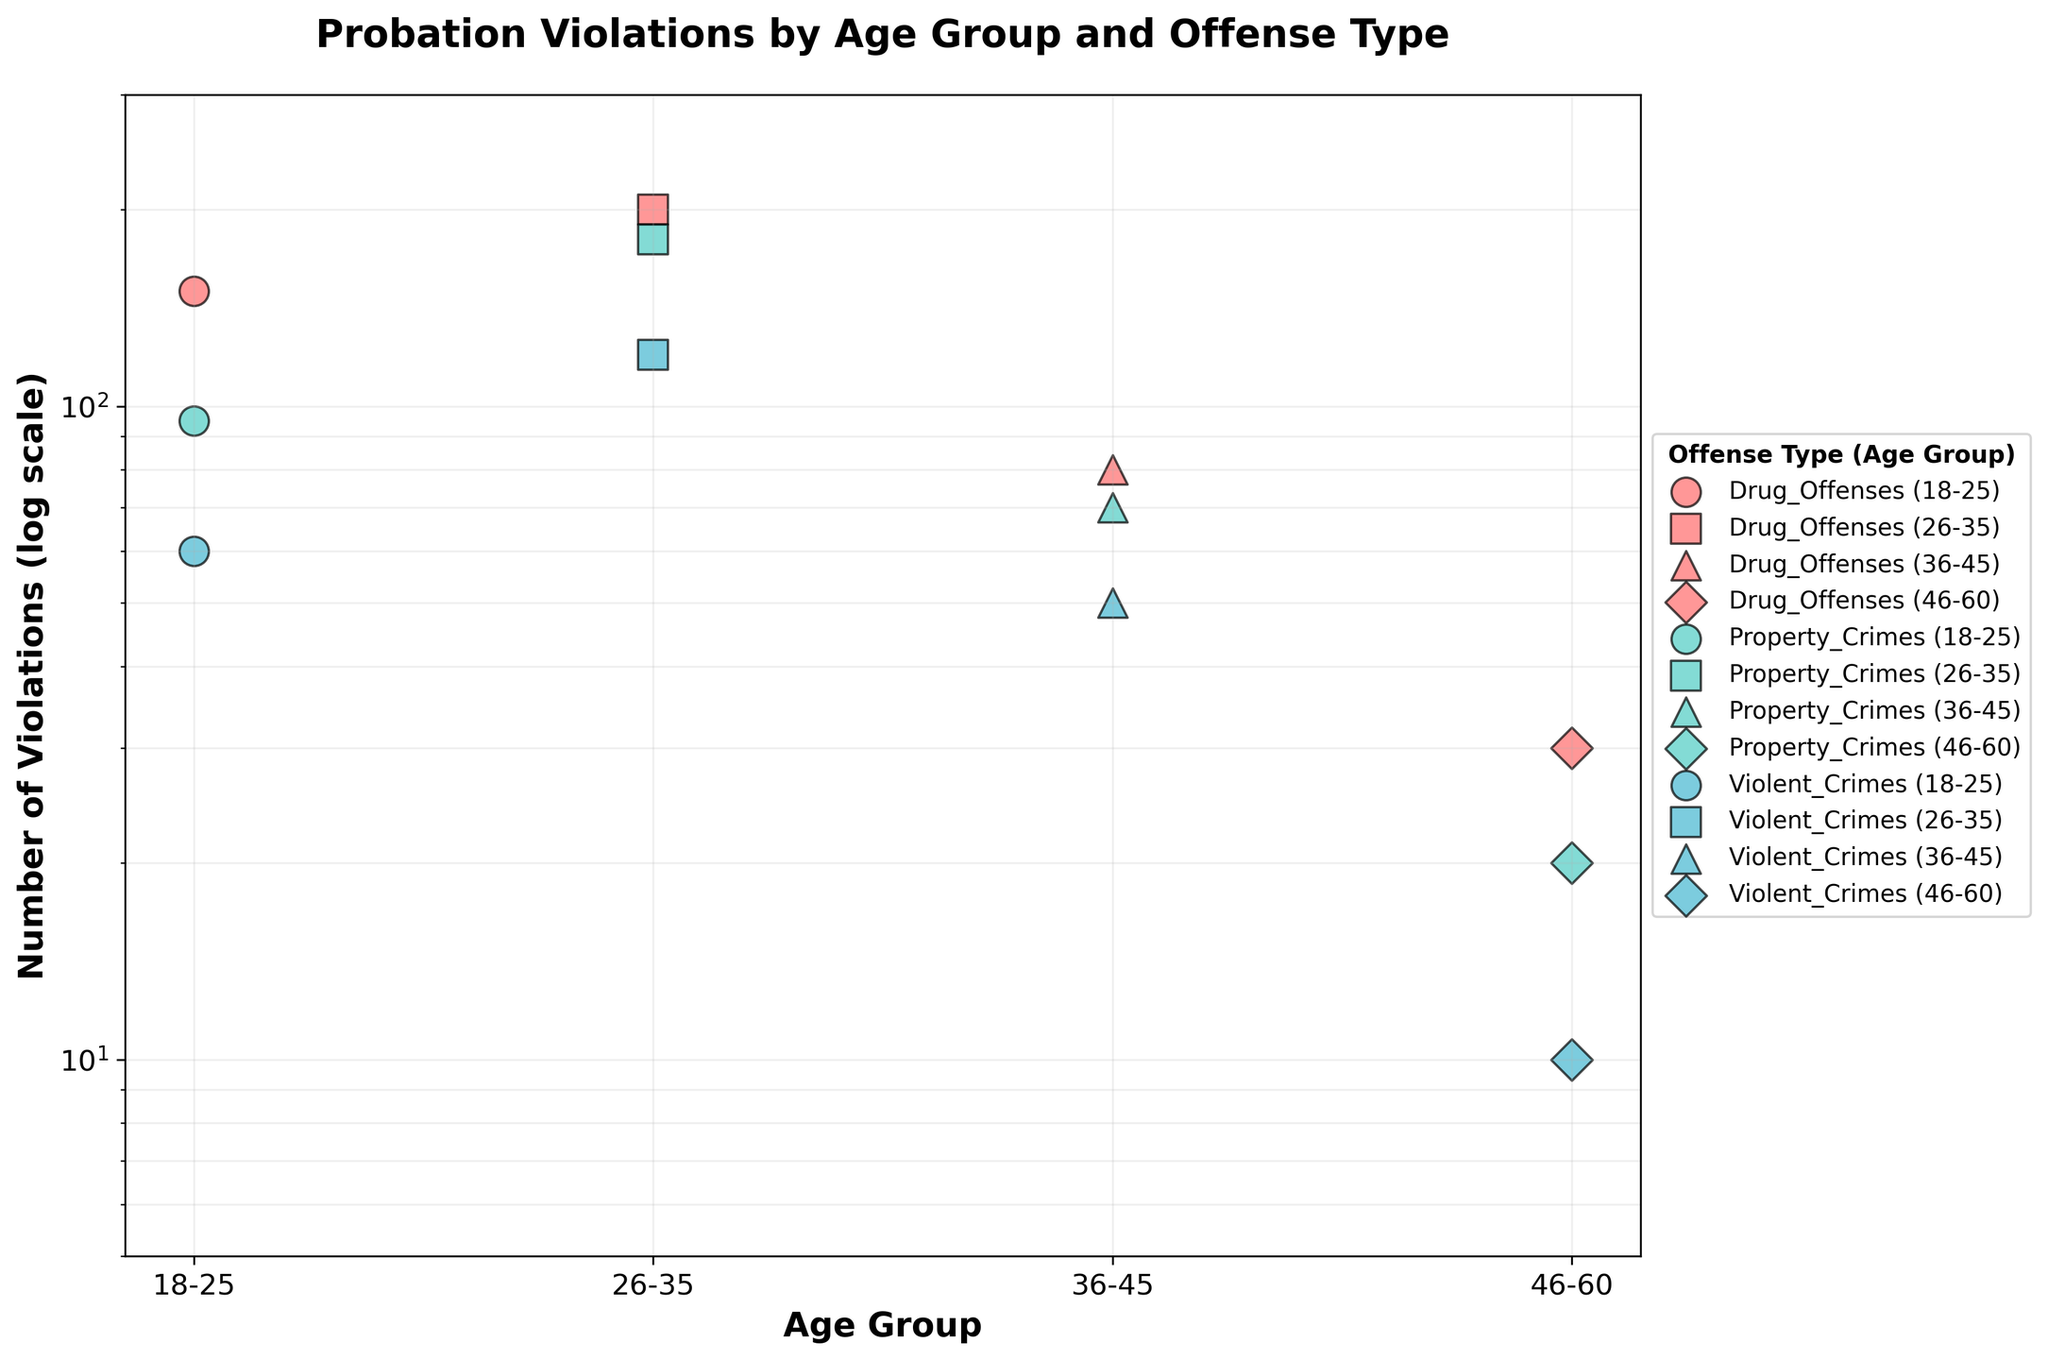Which age group has the highest number of probation violations in Drug Offenses? The highest number of violations for Drug Offenses is found by examining the data points for each age group and comparing their values. The 26-35 age group has the highest number of violations at 200.
Answer: 26-35 How many total probation violations were recorded for the 18-25 age group? Sum the values of probation violations across all offense types for the 18-25 age group: 150 (Drug Offenses) + 95 (Property Crimes) + 60 (Violent Crimes) = 305.
Answer: 305 What is the trend in the number of Violent Crimes violations as the age group increases? Visual inspection of Violent Crimes values across age groups shows the number decreases: 18-25 (60), 26-35 (120), 36-45 (50), 46-60 (10). The general trend is a significant decrease overall, with 26-35 being a notable peak.
Answer: Decreasing trend Which offense type has the fewest violations in the 46-60 age group? Examine the data points for the 46-60 age group: Drug Offenses (30), Property Crimes (20), Violent Crimes (10). The offense type with the fewest violations is Violent Crimes.
Answer: Violent Crimes Compare the total number of violations in the 18-25 group versus the 46-60 group. Sum the values for each group: 18-25 (150+95+60=305), 46-60 (30+20+10=60). Compare the sums: 305 (18-25) vs 60 (46-60). The 18-25 group has significantly more violations.
Answer: 18-25 has more Which age group has the smallest difference between the highest and lowest number of violations? Calculate the difference for each age group: 18-25 (150-60=90), 26-35 (200-120=80), 36-45 (80-50=30), 46-60 (30-10=20). The smallest difference is in the 46-60 age group.
Answer: 46-60 For the 26-35 age group, what offense type is recorded second highest in probation violations? Look at data points for the 26-35 age group: Drug Offenses (200), Property Crimes (180), Violent Crimes (120). The second highest is Property Crimes at 180.
Answer: Property Crimes How many more Property Crimes violations are there in the 26-35 age group compared to the 36-45 age group? Compare Property Crimes violations for each group: 180 (26-35) and 70 (36-45). Calculate the difference: 180 - 70 = 110.
Answer: 110 What is the log scale axis range for the number of violations? The y-axis is set to a logarithmic scale and ranges from 5 to 300 as per the visualization settings.
Answer: 5 to 300 